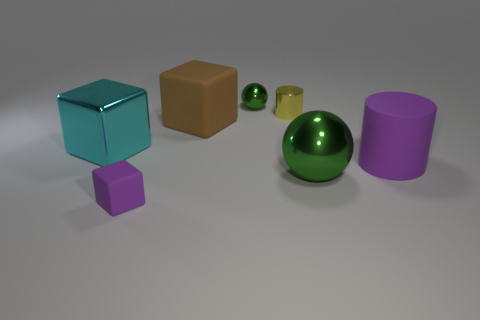If these objects were part of a larger scene, what could that be? If these objects were part of a larger scene, it could be a setting for a modern art installation that emphasizes geometric forms and colors. Alternatively, it could be a snapshot from a digital animation where each object represents a character or element within a narrative or educational program, exploring concepts such as geometry, spatial relations, or even physics. 